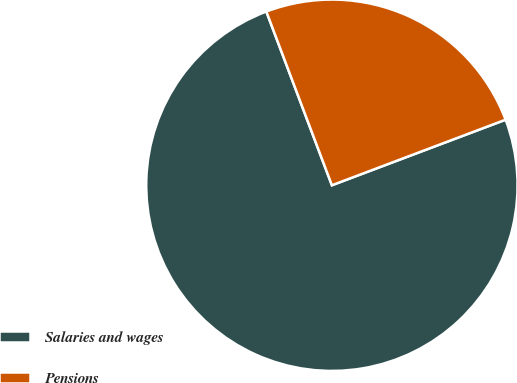<chart> <loc_0><loc_0><loc_500><loc_500><pie_chart><fcel>Salaries and wages<fcel>Pensions<nl><fcel>75.0%<fcel>25.0%<nl></chart> 